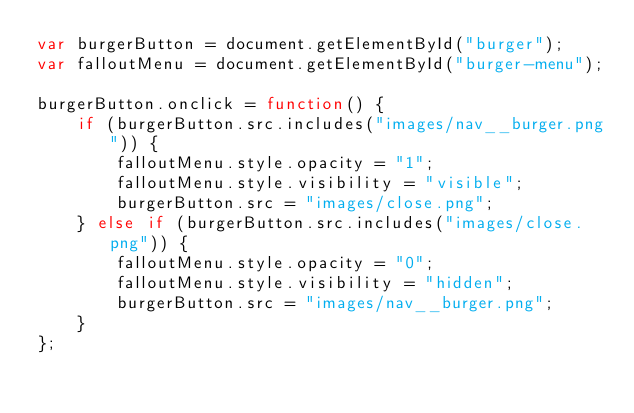Convert code to text. <code><loc_0><loc_0><loc_500><loc_500><_JavaScript_>var burgerButton = document.getElementById("burger");
var falloutMenu = document.getElementById("burger-menu");

burgerButton.onclick = function() {
    if (burgerButton.src.includes("images/nav__burger.png")) {
        falloutMenu.style.opacity = "1";
        falloutMenu.style.visibility = "visible";
        burgerButton.src = "images/close.png";
    } else if (burgerButton.src.includes("images/close.png")) {
        falloutMenu.style.opacity = "0";
        falloutMenu.style.visibility = "hidden";
        burgerButton.src = "images/nav__burger.png";
    }
};

</code> 